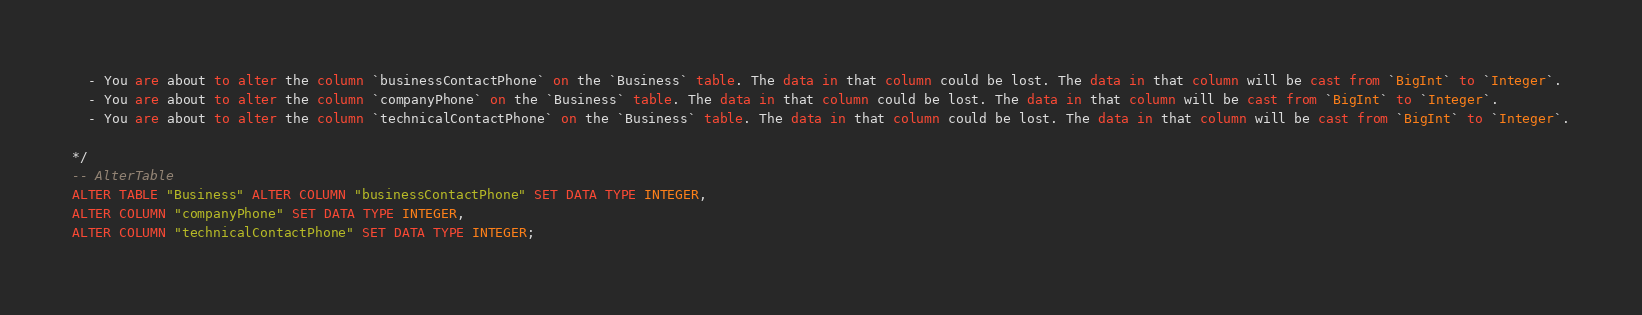Convert code to text. <code><loc_0><loc_0><loc_500><loc_500><_SQL_>  - You are about to alter the column `businessContactPhone` on the `Business` table. The data in that column could be lost. The data in that column will be cast from `BigInt` to `Integer`.
  - You are about to alter the column `companyPhone` on the `Business` table. The data in that column could be lost. The data in that column will be cast from `BigInt` to `Integer`.
  - You are about to alter the column `technicalContactPhone` on the `Business` table. The data in that column could be lost. The data in that column will be cast from `BigInt` to `Integer`.

*/
-- AlterTable
ALTER TABLE "Business" ALTER COLUMN "businessContactPhone" SET DATA TYPE INTEGER,
ALTER COLUMN "companyPhone" SET DATA TYPE INTEGER,
ALTER COLUMN "technicalContactPhone" SET DATA TYPE INTEGER;
</code> 